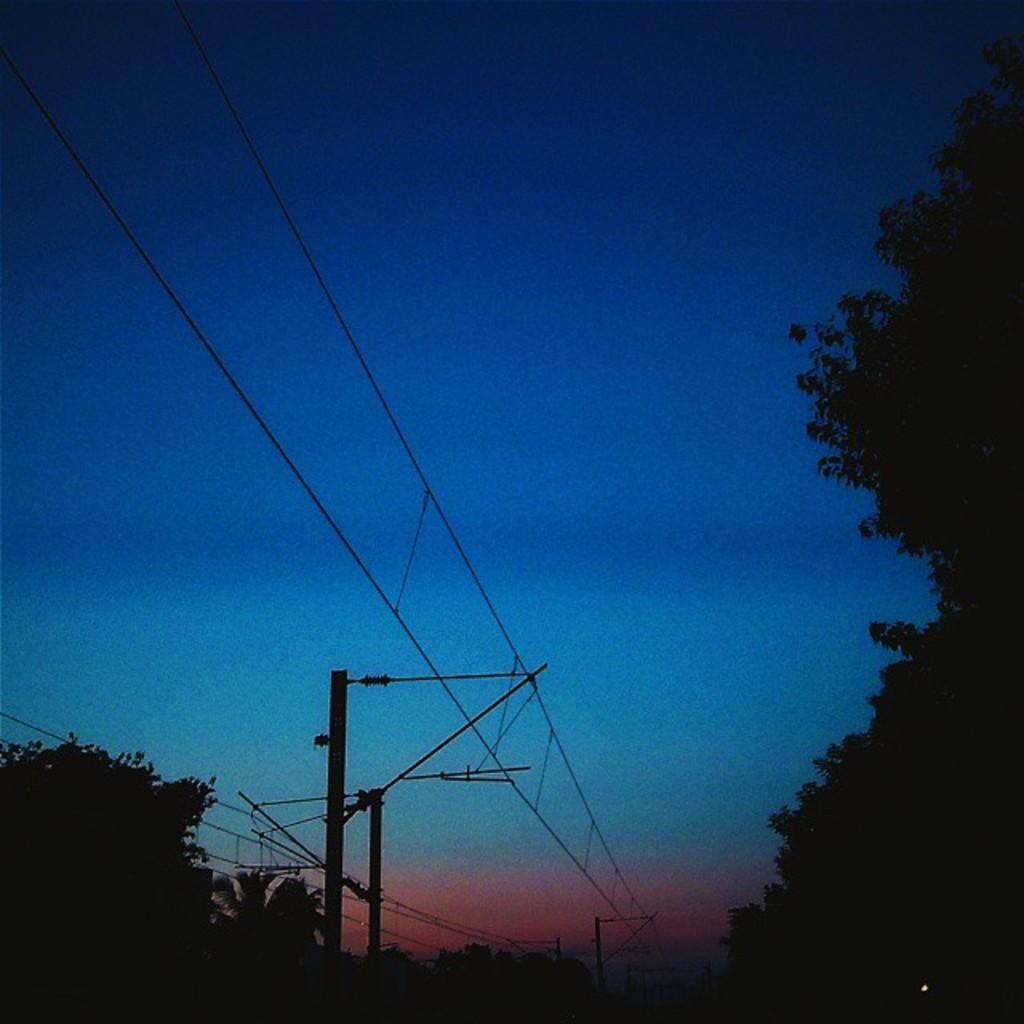What is located in the center of the image? There are poles and wires in the center of the image. What can be seen in the background of the image? There are trees and the sky visible in the background of the image. What type of wound can be seen on the pig in the image? There is no pig present in the image, and therefore no wound can be observed. 